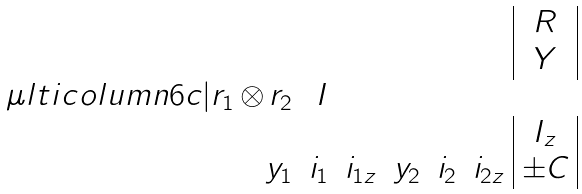Convert formula to latex. <formula><loc_0><loc_0><loc_500><loc_500>\begin{array} { r r r r r r | c | } & & & & & & { R } \\ & & & & & & Y \\ \mu l t i c o l u m n { 6 } { c | } { { r } _ { 1 } \, { \otimes } \, { r } _ { 2 } } & I \\ & & & & & & I _ { z } \\ y _ { 1 } & i _ { 1 } & i _ { 1 z } & y _ { 2 } & i _ { 2 } & i _ { 2 z } & \pm C \\ \end{array}</formula> 